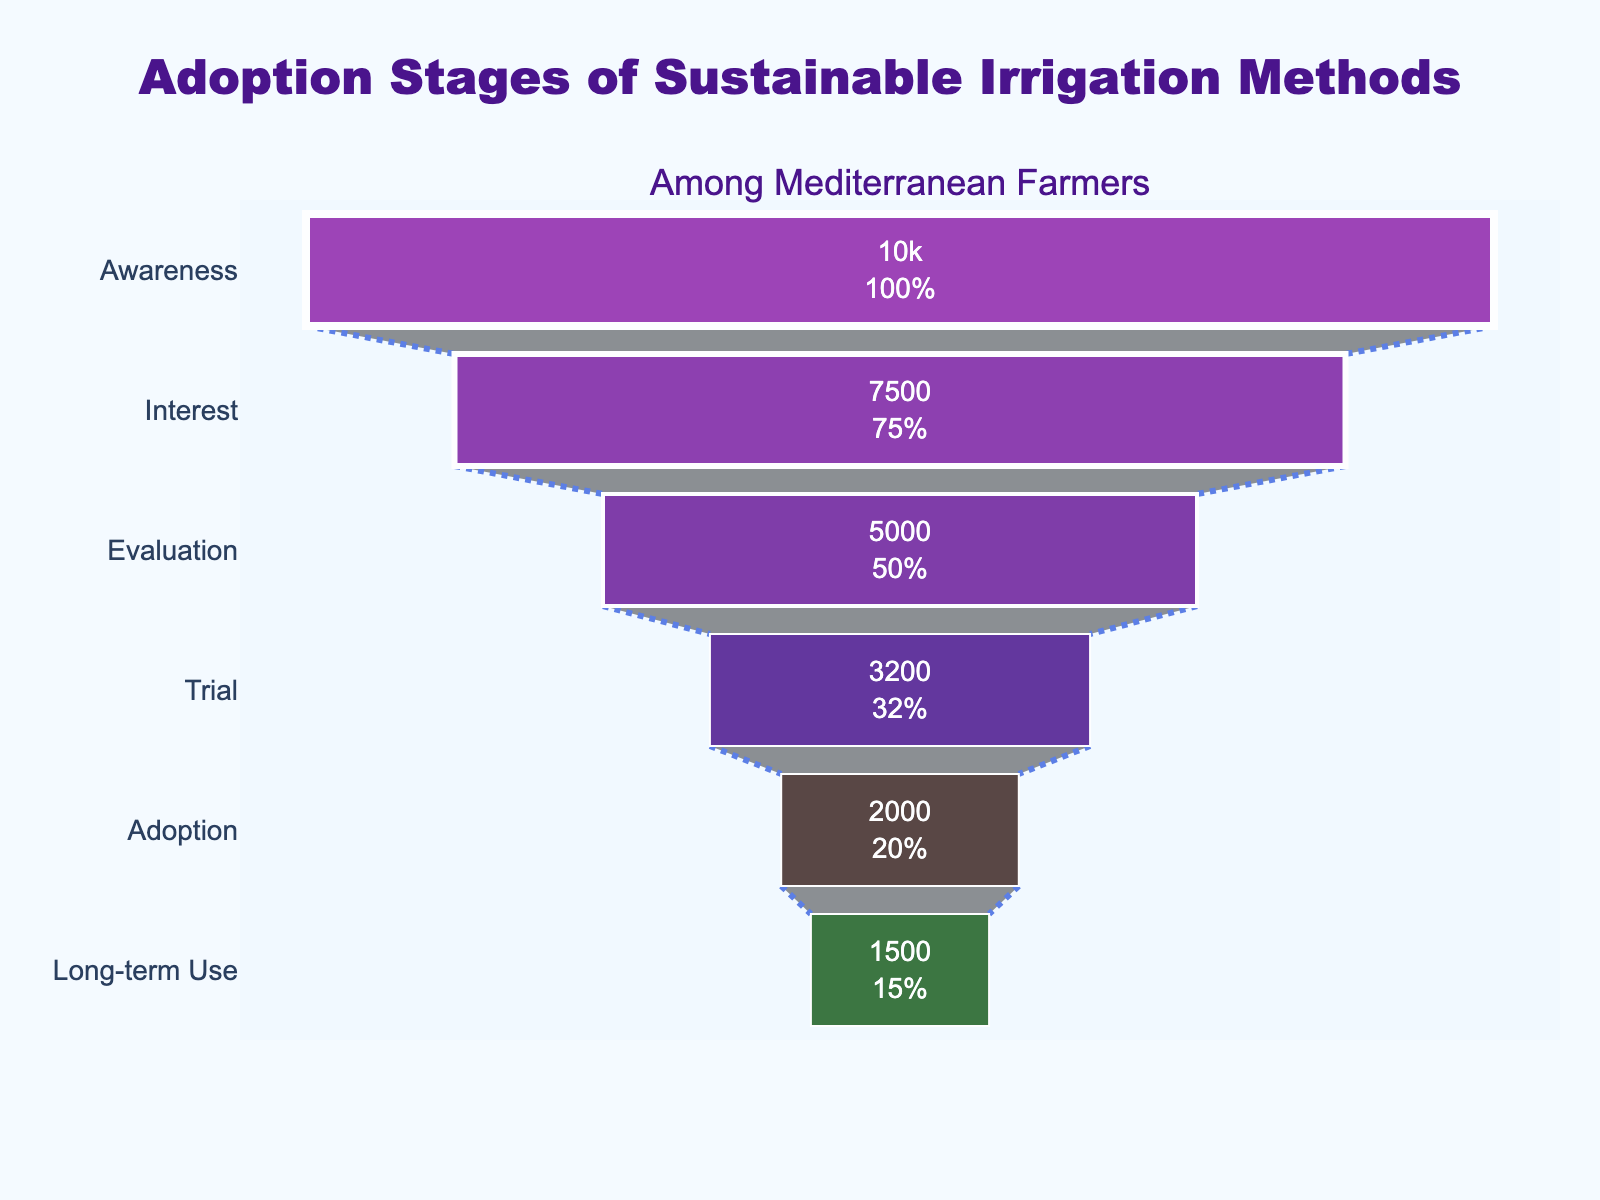What's the title of the figure? The title is displayed at the top of the figure. It reads "Adoption Stages of Sustainable Irrigation Methods".
Answer: Adoption Stages of Sustainable Irrigation Methods What percentage of farmers are in the Trial stage compared to those in the Awareness stage? The figure indicates the number of farmers in each stage. The Trial stage has 3,200 farmers and the Awareness stage has 10,000 farmers. The percentage is calculated as (3,200 / 10,000) * 100.
Answer: 32% How many farmers are interested in sustainable irrigation methods but have not yet evaluated them? The figure shows 7,500 farmers in the Interest stage and 5,000 farmers in the Evaluation stage. The difference represents those who are interested but have not yet evaluated. 7,500 - 5,000 = 2,500.
Answer: 2,500 Which stage sees the largest drop in the number of farmers? By examining the difference between consecutive stages, we see the largest drop occurs between the Interest (7,500) and Evaluation (5,000) stages, a difference of 2,500 farmers.
Answer: Between Interest and Evaluation What is the total number of farmers who proceed to the Adoption stage and beyond? Summing the number of farmers in the Adoption stage (2,000) and Long-term Use stage (1,500) gives the total. 2,000 + 1,500 = 3,500.
Answer: 3,500 What percentage of the initial farmers reach the Long-term Use stage? The initial number of farmers is 10,000, and 1,500 reach the Long-term Use stage. The percentage is (1,500 / 10,000) * 100.
Answer: 15% Which stage has the fewest number of farmers? Observing the figure, the stage with the fewest farmers is the Long-term Use stage with 1,500 farmers.
Answer: Long-term Use How many stages are included in this adoption funnel? Counting the stages listed in the figure gives a total of 6 stages: Awareness, Interest, Evaluation, Trial, Adoption, and Long-term Use.
Answer: 6 What is the percentage drop from the Evaluation stage to the Trial stage? The number of farmers in the Evaluation stage is 5,000 and in the Trial stage is 3,200. The percentage drop is calculated as ((5,000 - 3,200) / 5,000) * 100.
Answer: 36% How does the number of farmers in the Adoption stage compare to those in the Trial stage? Comparing the values in the figure, there are 3,200 farmers in the Trial stage and 2,000 in the Adoption stage, showing that the number of farmers increases in the Adoption stage.
Answer: Fewer farmers in the Adoption stage 